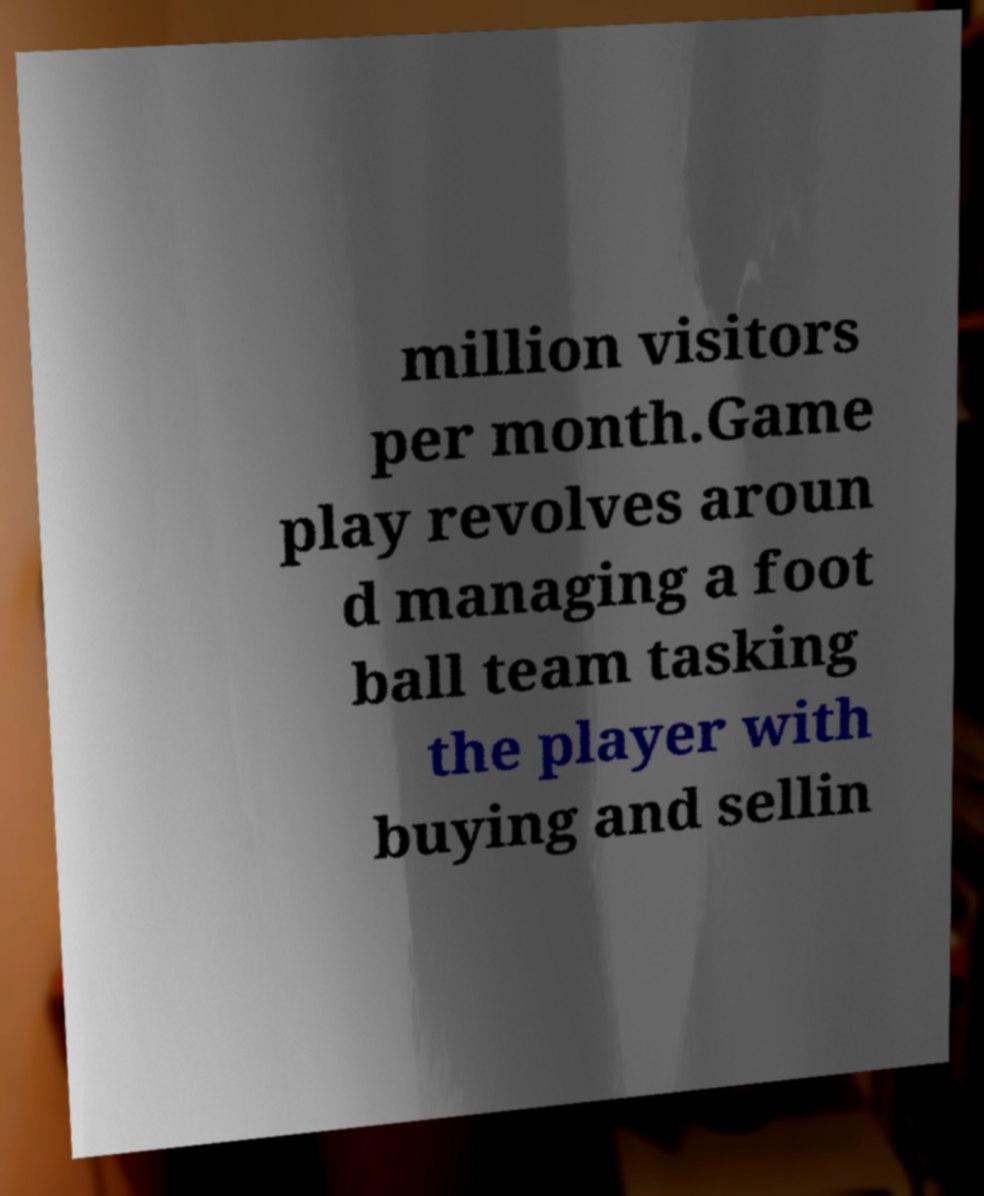Please identify and transcribe the text found in this image. million visitors per month.Game play revolves aroun d managing a foot ball team tasking the player with buying and sellin 